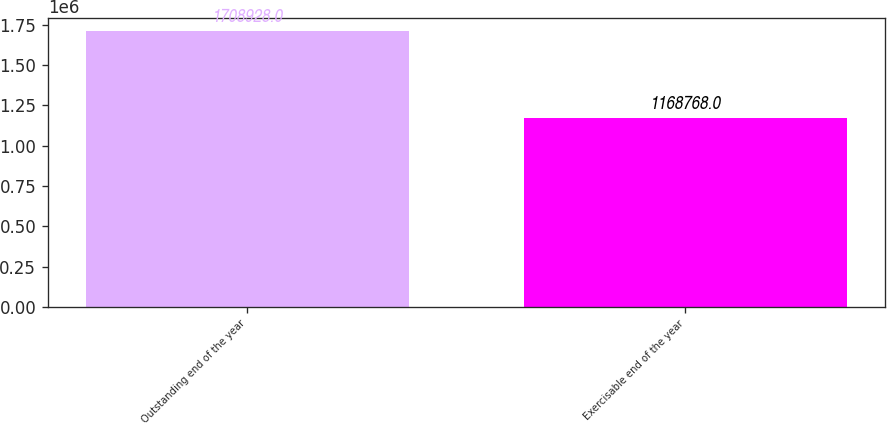Convert chart. <chart><loc_0><loc_0><loc_500><loc_500><bar_chart><fcel>Outstanding end of the year<fcel>Exercisable end of the year<nl><fcel>1.70893e+06<fcel>1.16877e+06<nl></chart> 